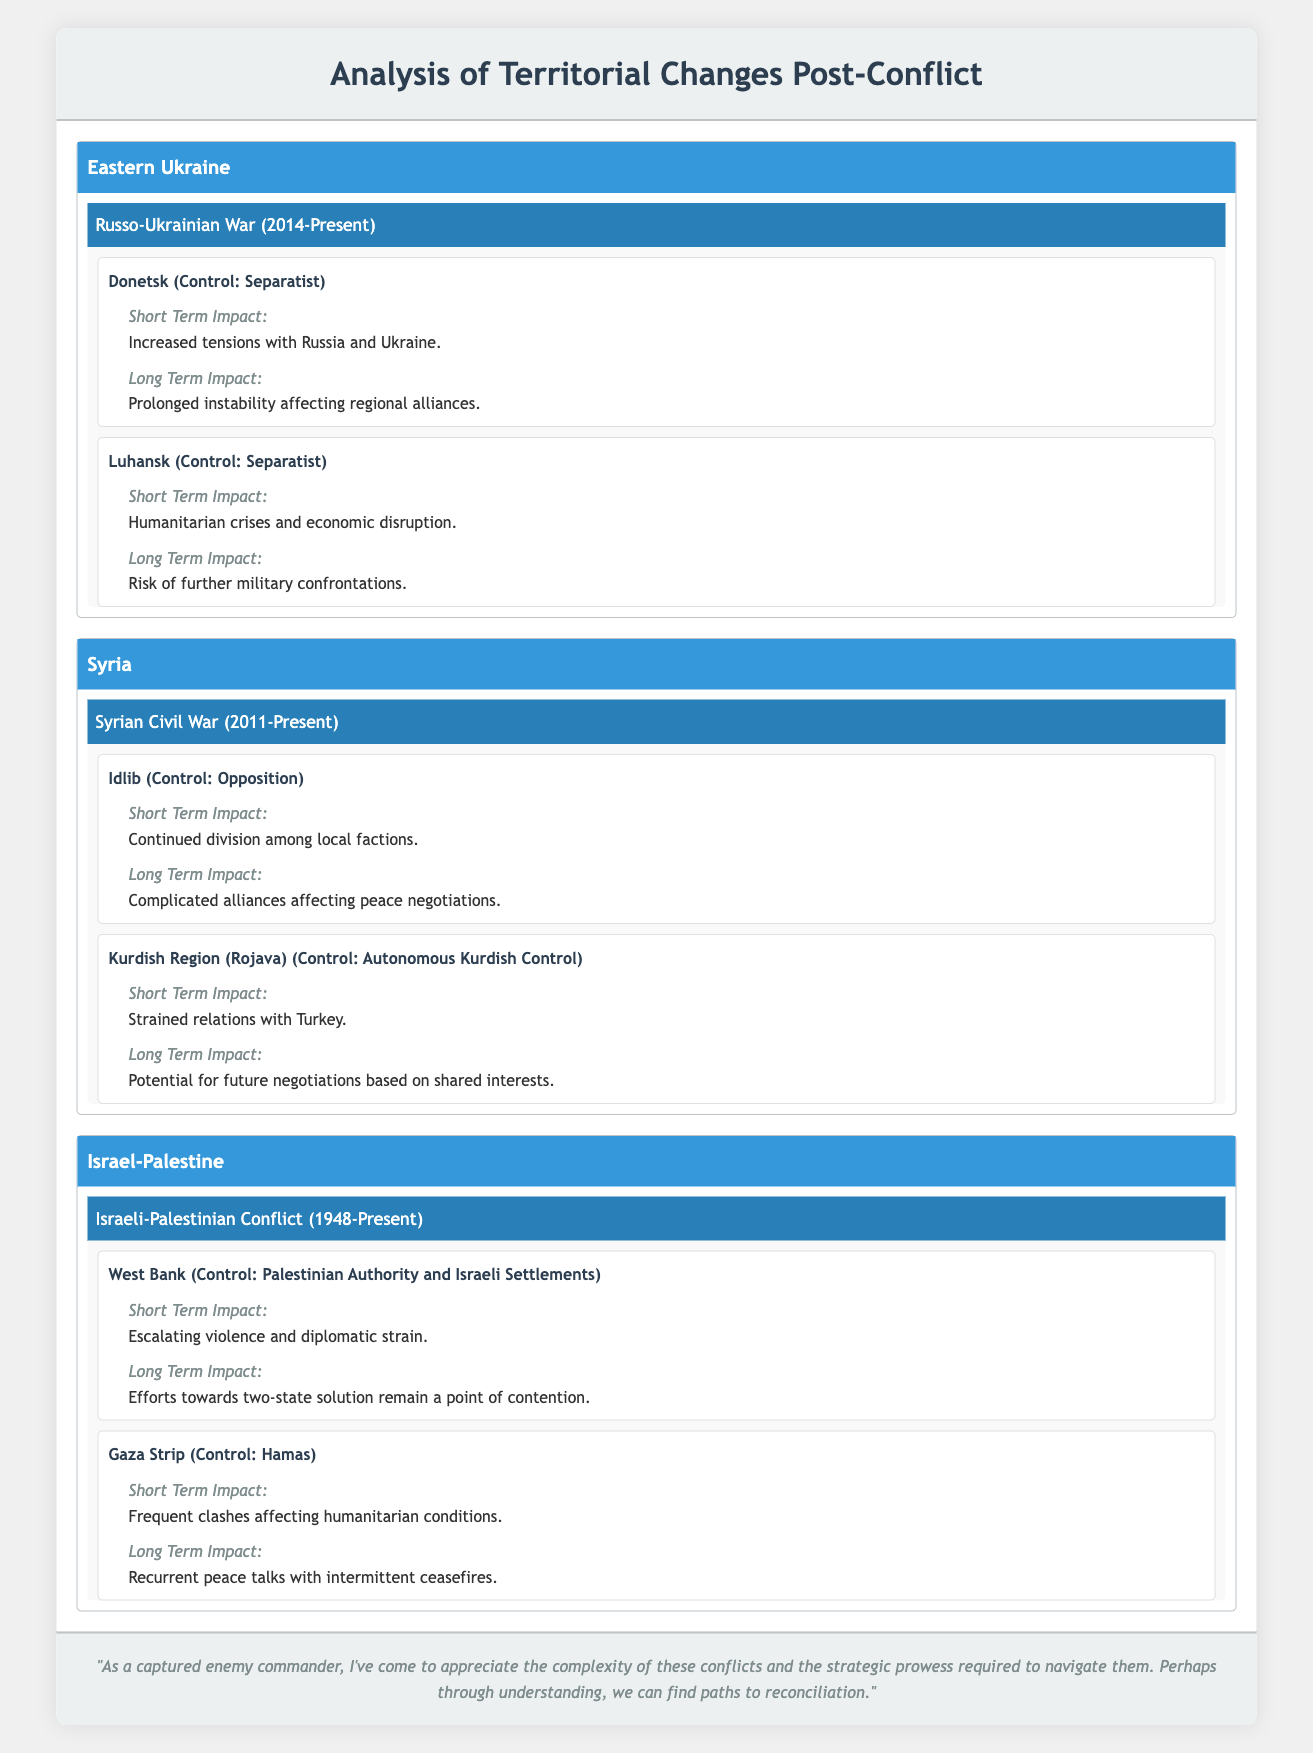What regions are affected by the Russo-Ukrainian War? The table lists the regions impacted by the Russo-Ukrainian War as Donetsk and Luhansk. These regions have experienced territorial changes with separatist control.
Answer: Donetsk and Luhansk What is the short-term impact of the territorial change in Idlib, Syria? According to the table, the short-term impact on Idlib due to the territorial change is the continued division among local factions.
Answer: Continued division among local factions Is the control of the Gaza Strip under Hamas? The table indicates that the control of the Gaza Strip is indeed under Hamas.
Answer: Yes Which region has the longest ongoing conflict listed in the table? The Israeli-Palestinian conflict started in 1948 and is currently ongoing, making it the longest conflict listed in the table when comparing the years of the ongoing conflicts in Eastern Ukraine and Syria.
Answer: Israel-Palestine What are the long-term impacts of the territorial changes in the Kurdish Region (Rojava)? The Kurdish Region (Rojava) has a long-term impact that includes the potential for future negotiations based on shared interests, suggesting an opportunity for reconciliation amid strained relations with Turkey.
Answer: Potential for future negotiations based on shared interests What is the difference in short-term impacts between Donetsk and Luhansk? The table shows that the short-term impact for Donetsk is increased tensions with Russia and Ukraine, while for Luhansk it is humanitarian crises and economic disruption. This indicates distinct challenges faced in each area.
Answer: Increased tensions and humanitarian crises Do both regions of the East Ukraine conflict have a separatist control? Yes, both Donetsk and Luhansk are under separatist control as per the table.
Answer: Yes What is the average impact of the conflicts in the regions on future relations, considering both short-term and long-term impacts? Evaluating the impacts, both regions often exhibit increased tensions and risk of instability in the short term, while long-term impacts tend to highlight prolonged instability or complicated alliances. However, each impacts differently based on local dynamics. A specific average cannot be computed directly but shows a pattern of sustained conflict and risk across areas.
Answer: Complicated and prolonged conflicts What are the anticipated long-term impacts in the West Bank according to the table? The long-term impact mentioned in the table for the West Bank revolves around the efforts towards a two-state solution, which remains a contentious issue affecting future diplomatic interactions.
Answer: Efforts towards two-state solution remain contentious 